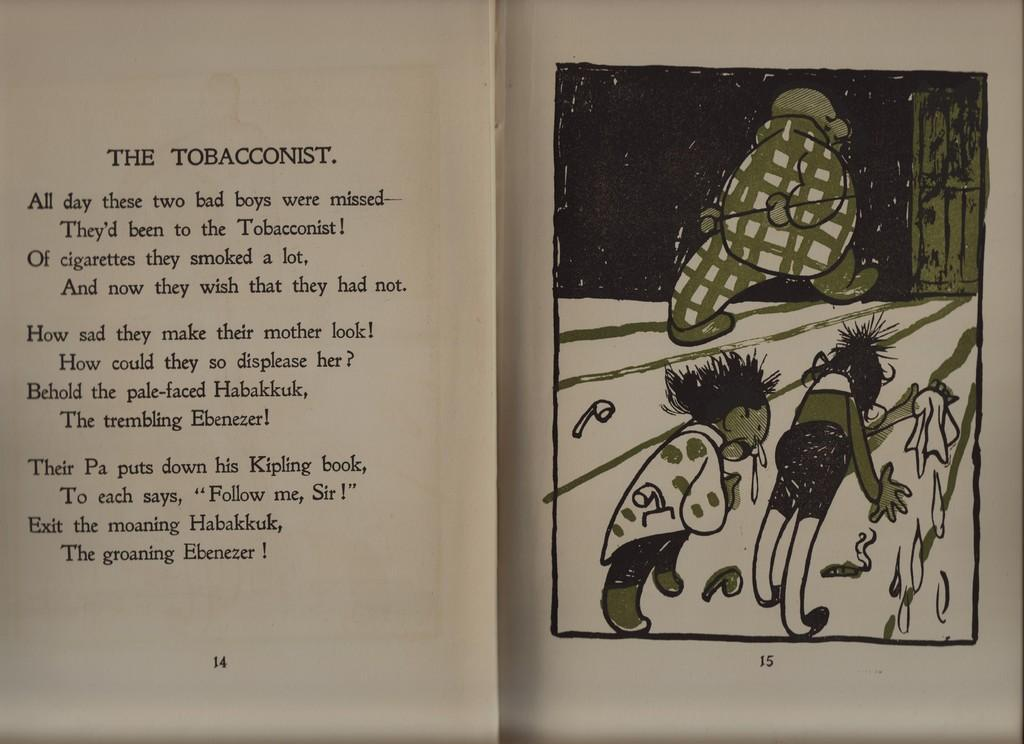<image>
Present a compact description of the photo's key features. the toboacconist is the name of the story opened up with the picture of three people 